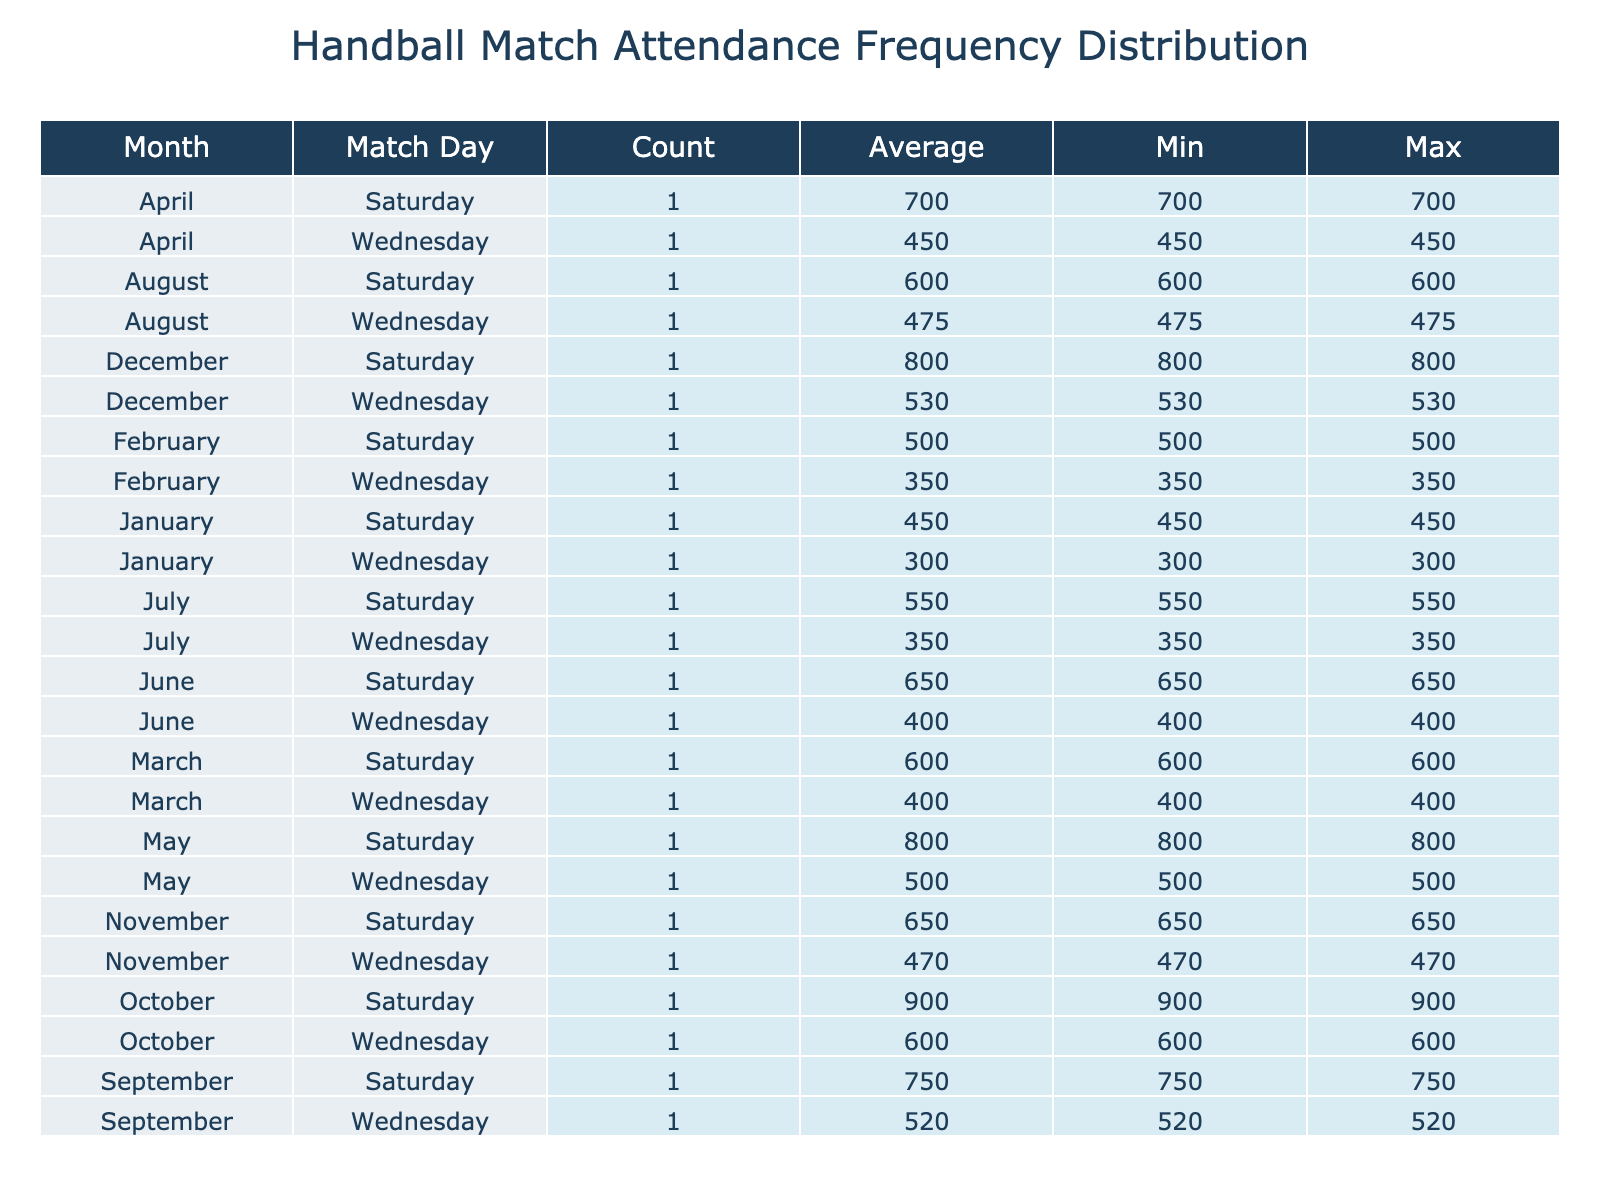What was the maximum attendance recorded in a match during the year? By looking at the table, the maximum attendance recorded is found in the October Saturday match, which has an attendance count of 900.
Answer: 900 In which month did the Saturday matches have the highest average attendance? To find this, I will calculate the average attendance for Saturday matches for each month. From the table, the values are: January (450), February (500), March (600), April (700), May (800), June (650), July (550), August (600), September (750), October (900), November (650), and December (800). The highest average attendance is found in October with 900.
Answer: October Does the attendance on Wednesday matches exceed that of Saturday matches in any month? By reviewing the attendance figures, we see no Wednesdays have counts exceeding Saturday matches. For all months, the highest Wednesday count (600) is less than or equal to the Saturday counts for those months.
Answer: No What was the average attendance for all matches played in May? To compute this, we take the attendances for May (Saturday: 800, Wednesday: 500), sum them up to get a total of 1300, and then divide by the number of matches, which is 2. Thus, 1300 divided by 2 equals 650.
Answer: 650 What is the difference between the average attendance on Saturdays and Wednesdays for the month with the highest attendance overall? The month with the highest attendance overall is October. The average attendance for Saturdays in October is 900, and for Wednesdays, it's 600. The difference is 900 - 600 = 300.
Answer: 300 In which month did Wednesday matches have the lowest minimum attendance? By examining the Wednesday row for each month, the lowest minimum attendance is January with a count of 300.
Answer: January Is the attendance on Saturday matches during the summer months (June, July, August) generally higher than 600? Checking the Saturday attendance, we have June (650), July (550), and August (600). Since July is less than 600, the answer is no; not all summer months exceed an attendance of 600.
Answer: No Which month had the highest total attendance when combining both Saturday and Wednesday matches? To find this, I sum the attendance for each month. The totals are: January (750), February (850), March (1000), April (1150), May (1300), June (1050), July (900), August (1075), September (1270), October (1500), November (1120), and December (1330). The highest total is in October with 1500.
Answer: October 